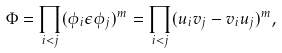<formula> <loc_0><loc_0><loc_500><loc_500>\Phi = \prod _ { i < j } ( \phi _ { i } \epsilon \phi _ { j } ) ^ { m } = \prod _ { i < j } ( u _ { i } v _ { j } - v _ { i } u _ { j } ) ^ { m } ,</formula> 